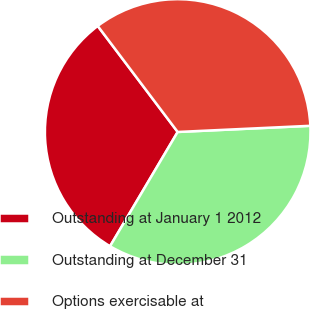Convert chart. <chart><loc_0><loc_0><loc_500><loc_500><pie_chart><fcel>Outstanding at January 1 2012<fcel>Outstanding at December 31<fcel>Options exercisable at<nl><fcel>31.21%<fcel>34.25%<fcel>34.55%<nl></chart> 